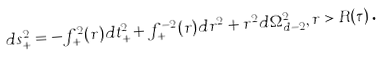Convert formula to latex. <formula><loc_0><loc_0><loc_500><loc_500>d s _ { + } ^ { 2 } = - f _ { + } ^ { 2 } ( r ) d t _ { + } ^ { 2 } + f _ { + } ^ { - 2 } ( r ) d r ^ { 2 } + r ^ { 2 } d \Omega _ { d - 2 } ^ { 2 } , r > R ( \tau ) \text {.}</formula> 